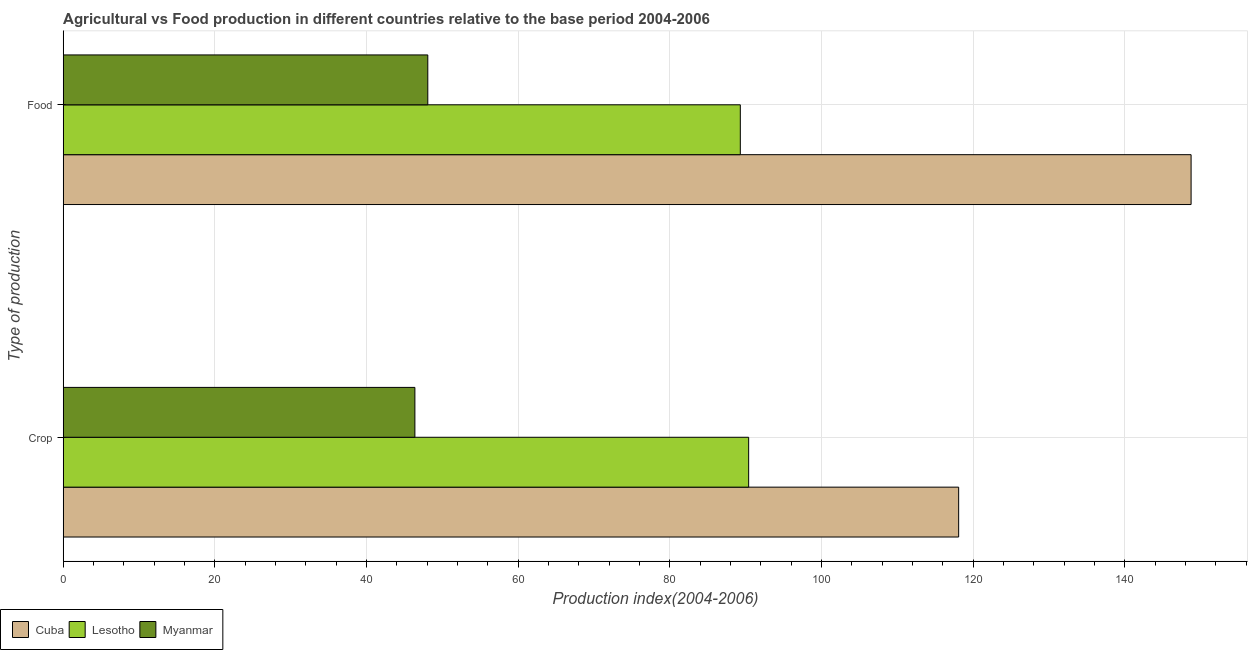How many different coloured bars are there?
Your answer should be compact. 3. How many groups of bars are there?
Provide a succinct answer. 2. Are the number of bars on each tick of the Y-axis equal?
Make the answer very short. Yes. How many bars are there on the 2nd tick from the top?
Offer a very short reply. 3. How many bars are there on the 2nd tick from the bottom?
Provide a short and direct response. 3. What is the label of the 1st group of bars from the top?
Keep it short and to the point. Food. What is the crop production index in Cuba?
Offer a terse response. 118.07. Across all countries, what is the maximum crop production index?
Keep it short and to the point. 118.07. Across all countries, what is the minimum food production index?
Your response must be concise. 48.07. In which country was the crop production index maximum?
Make the answer very short. Cuba. In which country was the food production index minimum?
Provide a succinct answer. Myanmar. What is the total crop production index in the graph?
Offer a terse response. 254.82. What is the difference between the crop production index in Cuba and that in Myanmar?
Give a very brief answer. 71.7. What is the difference between the food production index in Myanmar and the crop production index in Lesotho?
Keep it short and to the point. -42.31. What is the average food production index per country?
Make the answer very short. 95.36. What is the difference between the crop production index and food production index in Myanmar?
Your response must be concise. -1.7. In how many countries, is the food production index greater than 84 ?
Ensure brevity in your answer.  2. What is the ratio of the crop production index in Myanmar to that in Lesotho?
Keep it short and to the point. 0.51. What does the 3rd bar from the top in Crop represents?
Offer a terse response. Cuba. What does the 3rd bar from the bottom in Crop represents?
Your answer should be very brief. Myanmar. How many countries are there in the graph?
Offer a very short reply. 3. Does the graph contain any zero values?
Keep it short and to the point. No. Where does the legend appear in the graph?
Your response must be concise. Bottom left. What is the title of the graph?
Make the answer very short. Agricultural vs Food production in different countries relative to the base period 2004-2006. Does "High income: OECD" appear as one of the legend labels in the graph?
Ensure brevity in your answer.  No. What is the label or title of the X-axis?
Offer a terse response. Production index(2004-2006). What is the label or title of the Y-axis?
Make the answer very short. Type of production. What is the Production index(2004-2006) in Cuba in Crop?
Your response must be concise. 118.07. What is the Production index(2004-2006) of Lesotho in Crop?
Give a very brief answer. 90.38. What is the Production index(2004-2006) of Myanmar in Crop?
Give a very brief answer. 46.37. What is the Production index(2004-2006) in Cuba in Food?
Provide a short and direct response. 148.72. What is the Production index(2004-2006) in Lesotho in Food?
Your answer should be very brief. 89.28. What is the Production index(2004-2006) in Myanmar in Food?
Make the answer very short. 48.07. Across all Type of production, what is the maximum Production index(2004-2006) in Cuba?
Keep it short and to the point. 148.72. Across all Type of production, what is the maximum Production index(2004-2006) in Lesotho?
Offer a very short reply. 90.38. Across all Type of production, what is the maximum Production index(2004-2006) of Myanmar?
Offer a very short reply. 48.07. Across all Type of production, what is the minimum Production index(2004-2006) of Cuba?
Your response must be concise. 118.07. Across all Type of production, what is the minimum Production index(2004-2006) of Lesotho?
Give a very brief answer. 89.28. Across all Type of production, what is the minimum Production index(2004-2006) in Myanmar?
Your answer should be compact. 46.37. What is the total Production index(2004-2006) of Cuba in the graph?
Give a very brief answer. 266.79. What is the total Production index(2004-2006) in Lesotho in the graph?
Make the answer very short. 179.66. What is the total Production index(2004-2006) in Myanmar in the graph?
Give a very brief answer. 94.44. What is the difference between the Production index(2004-2006) in Cuba in Crop and that in Food?
Your response must be concise. -30.65. What is the difference between the Production index(2004-2006) in Cuba in Crop and the Production index(2004-2006) in Lesotho in Food?
Your response must be concise. 28.79. What is the difference between the Production index(2004-2006) of Cuba in Crop and the Production index(2004-2006) of Myanmar in Food?
Your response must be concise. 70. What is the difference between the Production index(2004-2006) in Lesotho in Crop and the Production index(2004-2006) in Myanmar in Food?
Your response must be concise. 42.31. What is the average Production index(2004-2006) of Cuba per Type of production?
Ensure brevity in your answer.  133.4. What is the average Production index(2004-2006) of Lesotho per Type of production?
Ensure brevity in your answer.  89.83. What is the average Production index(2004-2006) of Myanmar per Type of production?
Ensure brevity in your answer.  47.22. What is the difference between the Production index(2004-2006) in Cuba and Production index(2004-2006) in Lesotho in Crop?
Give a very brief answer. 27.69. What is the difference between the Production index(2004-2006) of Cuba and Production index(2004-2006) of Myanmar in Crop?
Offer a terse response. 71.7. What is the difference between the Production index(2004-2006) in Lesotho and Production index(2004-2006) in Myanmar in Crop?
Ensure brevity in your answer.  44.01. What is the difference between the Production index(2004-2006) of Cuba and Production index(2004-2006) of Lesotho in Food?
Your answer should be compact. 59.44. What is the difference between the Production index(2004-2006) in Cuba and Production index(2004-2006) in Myanmar in Food?
Offer a terse response. 100.65. What is the difference between the Production index(2004-2006) of Lesotho and Production index(2004-2006) of Myanmar in Food?
Your answer should be compact. 41.21. What is the ratio of the Production index(2004-2006) of Cuba in Crop to that in Food?
Offer a terse response. 0.79. What is the ratio of the Production index(2004-2006) of Lesotho in Crop to that in Food?
Offer a very short reply. 1.01. What is the ratio of the Production index(2004-2006) in Myanmar in Crop to that in Food?
Your answer should be very brief. 0.96. What is the difference between the highest and the second highest Production index(2004-2006) of Cuba?
Your answer should be compact. 30.65. What is the difference between the highest and the second highest Production index(2004-2006) of Lesotho?
Make the answer very short. 1.1. What is the difference between the highest and the lowest Production index(2004-2006) of Cuba?
Provide a succinct answer. 30.65. What is the difference between the highest and the lowest Production index(2004-2006) in Myanmar?
Make the answer very short. 1.7. 